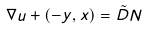<formula> <loc_0><loc_0><loc_500><loc_500>\nabla u + ( - y , x ) = \tilde { D } N</formula> 